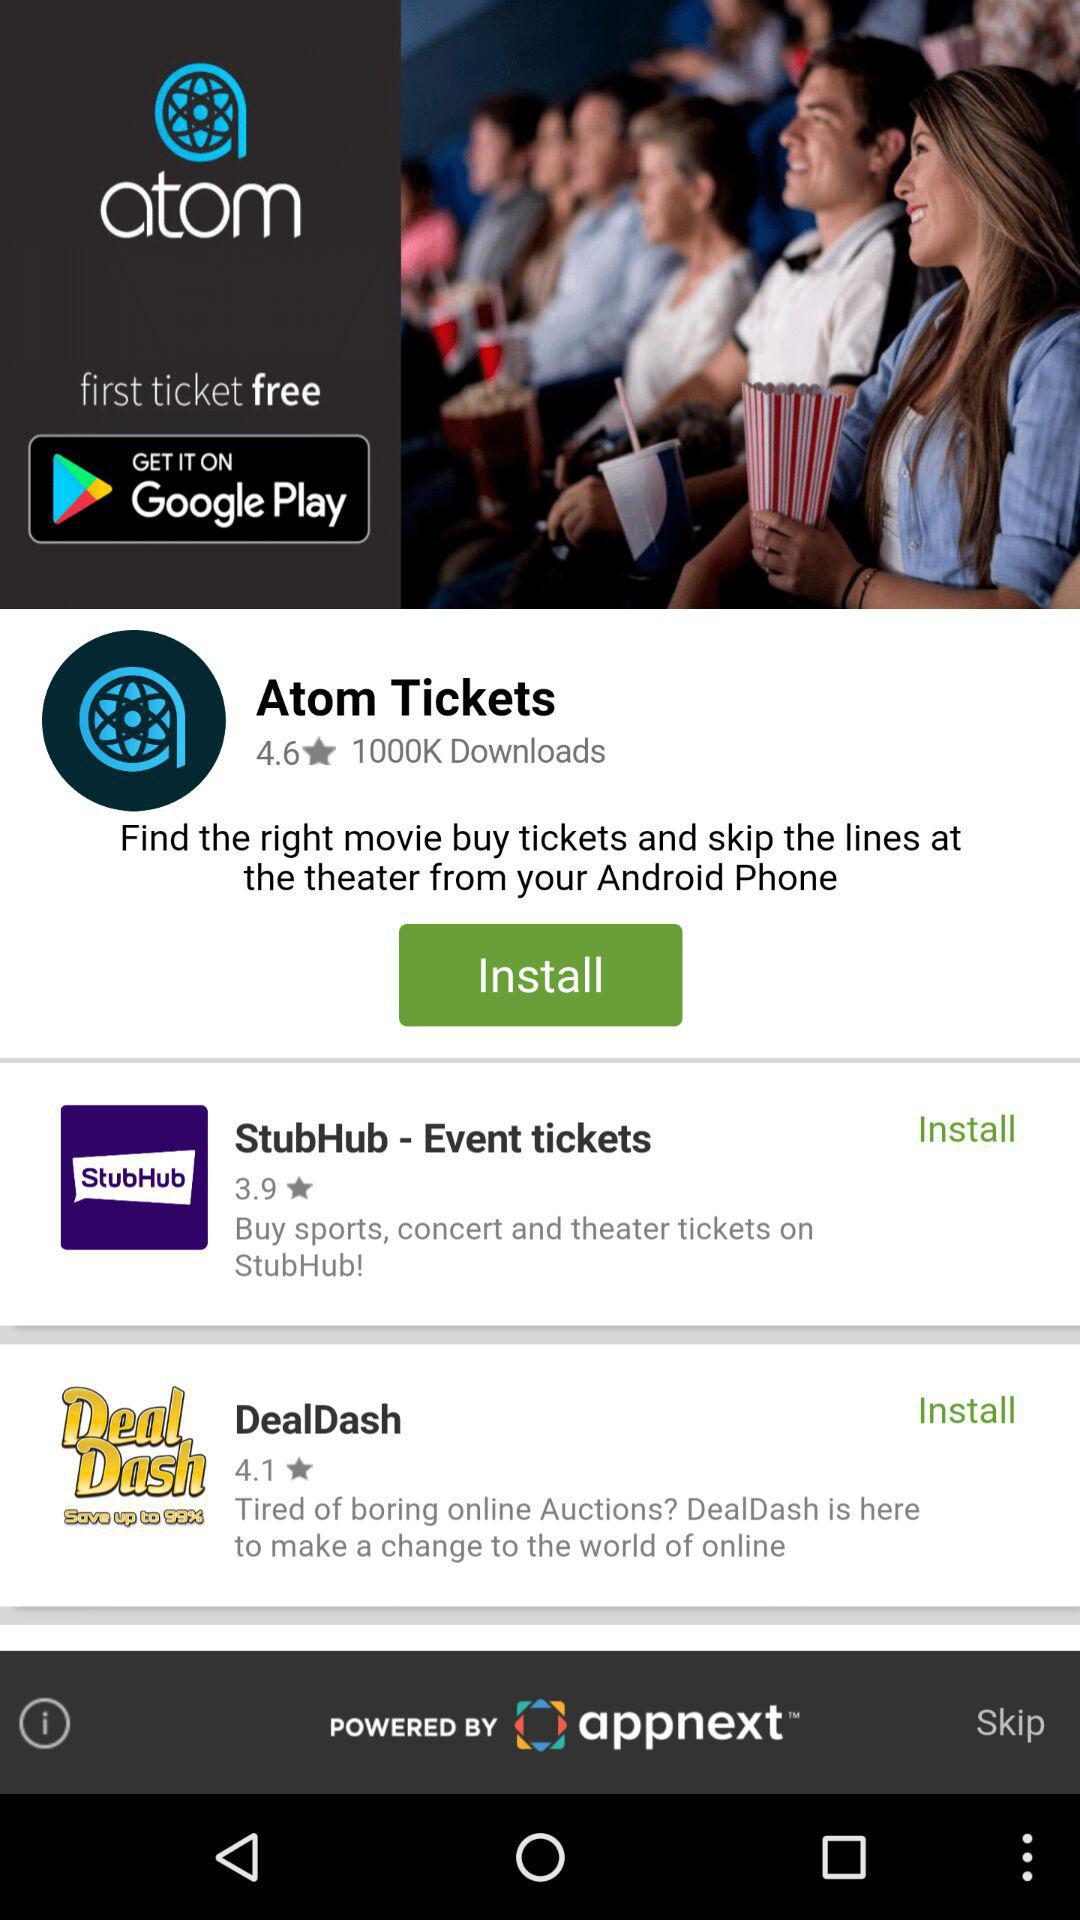What is the number of downloads? There are 1000K downloads. 